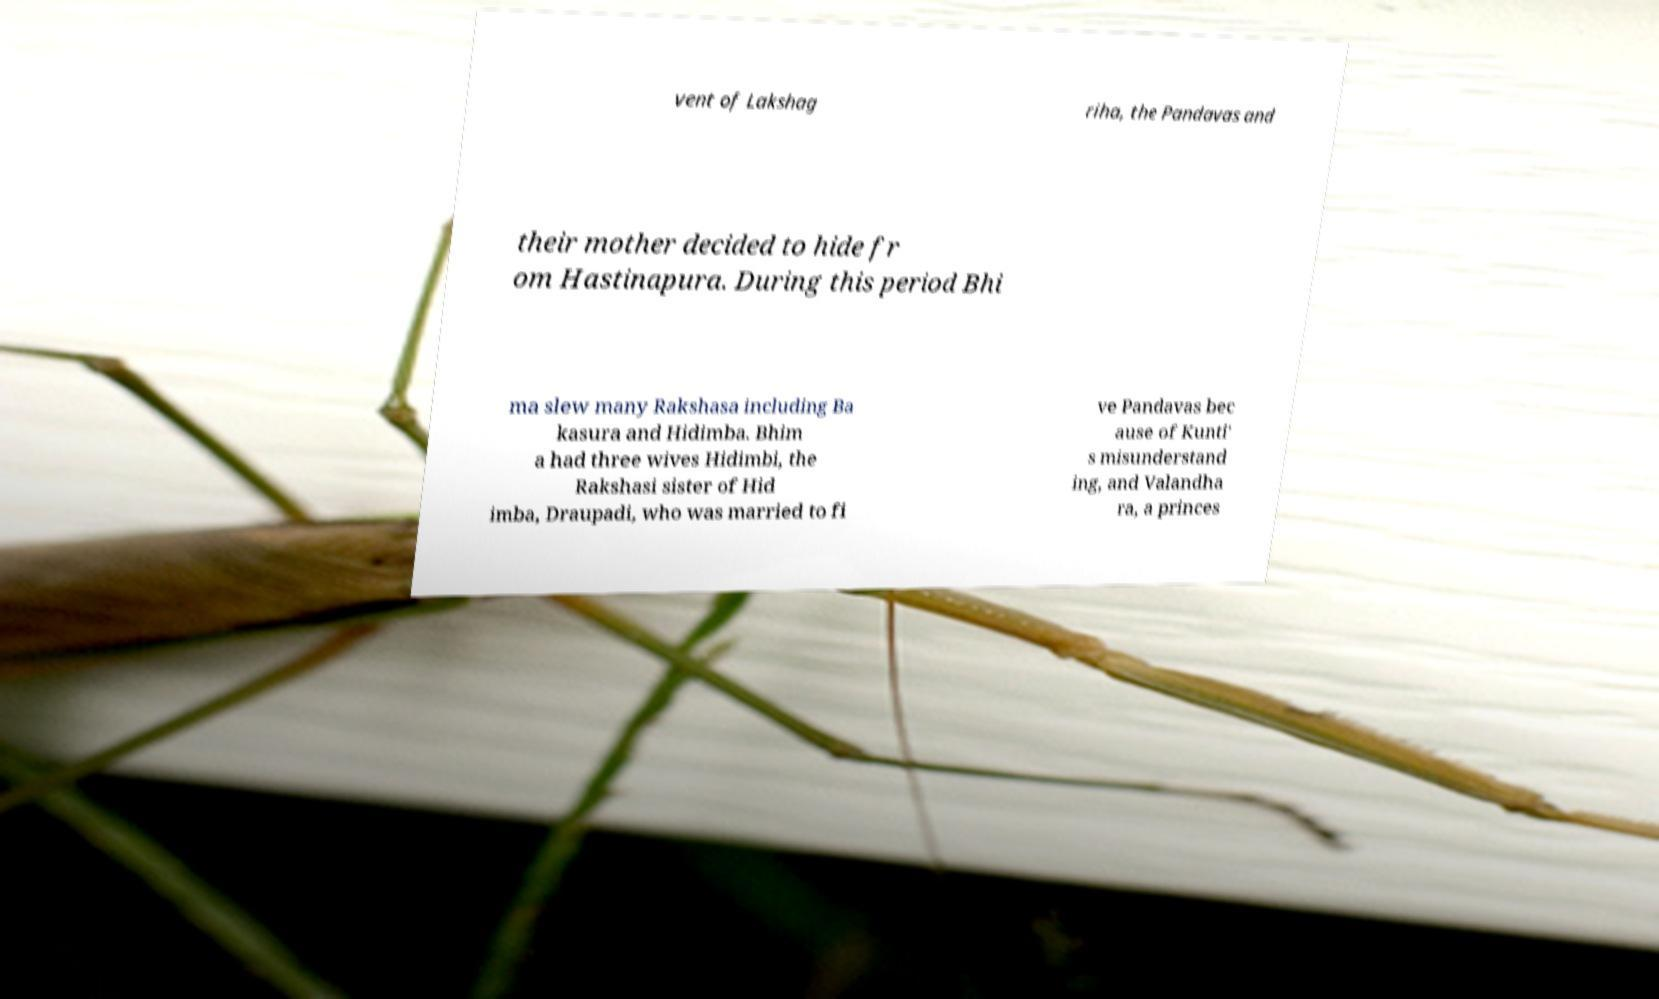Please read and relay the text visible in this image. What does it say? vent of Lakshag riha, the Pandavas and their mother decided to hide fr om Hastinapura. During this period Bhi ma slew many Rakshasa including Ba kasura and Hidimba. Bhim a had three wives Hidimbi, the Rakshasi sister of Hid imba, Draupadi, who was married to fi ve Pandavas bec ause of Kunti' s misunderstand ing, and Valandha ra, a princes 